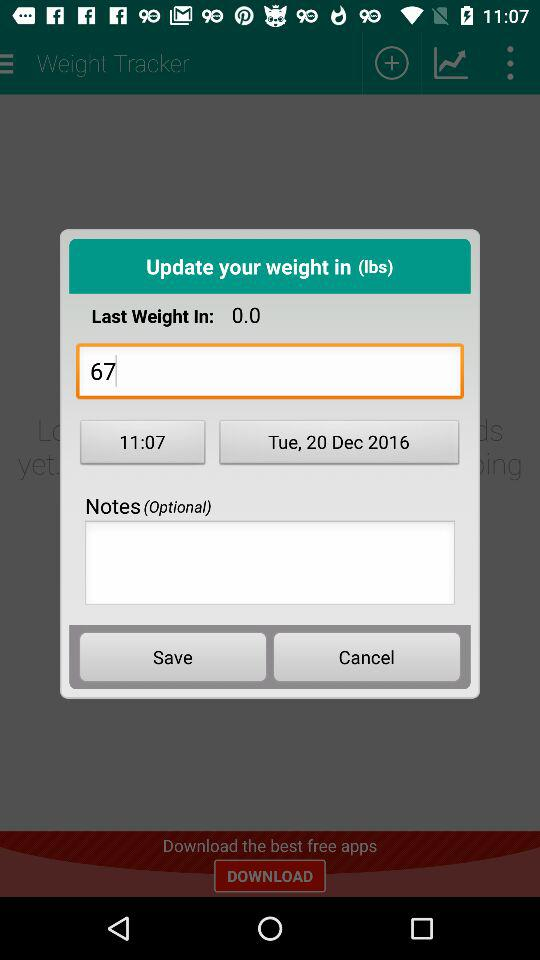What is the time? The time is 11:07. 